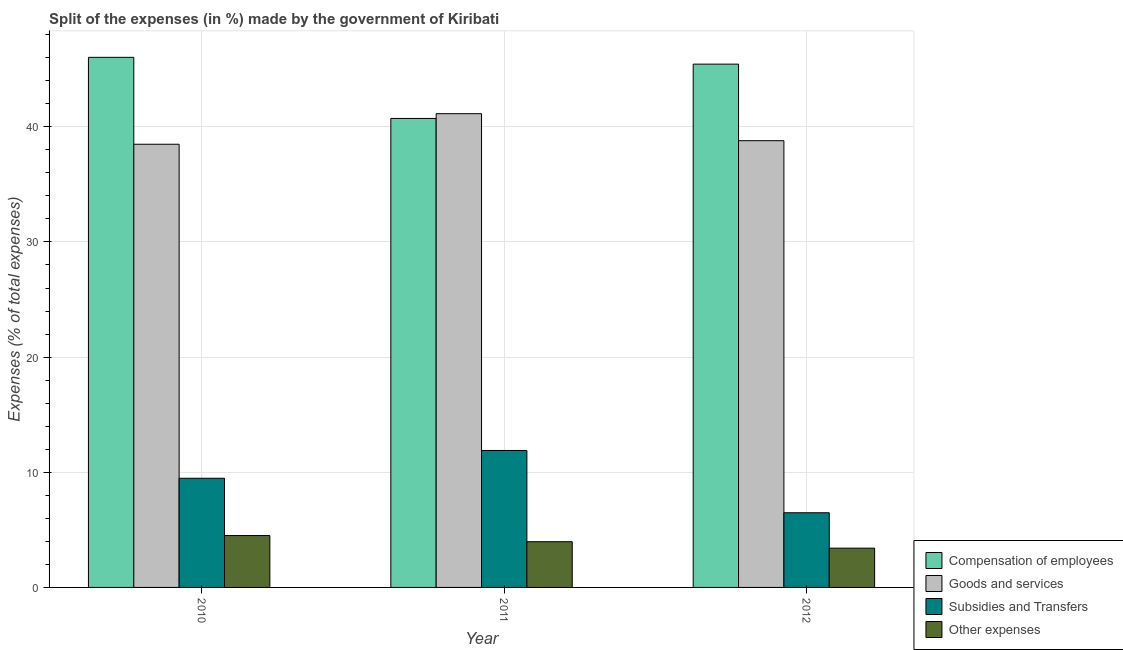How many groups of bars are there?
Your answer should be compact. 3. How many bars are there on the 3rd tick from the right?
Your answer should be very brief. 4. What is the label of the 3rd group of bars from the left?
Make the answer very short. 2012. What is the percentage of amount spent on subsidies in 2011?
Keep it short and to the point. 11.89. Across all years, what is the maximum percentage of amount spent on other expenses?
Offer a terse response. 4.51. Across all years, what is the minimum percentage of amount spent on subsidies?
Keep it short and to the point. 6.48. In which year was the percentage of amount spent on other expenses maximum?
Offer a very short reply. 2010. In which year was the percentage of amount spent on other expenses minimum?
Your answer should be very brief. 2012. What is the total percentage of amount spent on goods and services in the graph?
Your response must be concise. 118.42. What is the difference between the percentage of amount spent on goods and services in 2010 and that in 2012?
Your answer should be compact. -0.31. What is the difference between the percentage of amount spent on goods and services in 2012 and the percentage of amount spent on compensation of employees in 2010?
Offer a very short reply. 0.31. What is the average percentage of amount spent on other expenses per year?
Give a very brief answer. 3.96. In how many years, is the percentage of amount spent on other expenses greater than 26 %?
Provide a succinct answer. 0. What is the ratio of the percentage of amount spent on goods and services in 2011 to that in 2012?
Give a very brief answer. 1.06. Is the percentage of amount spent on other expenses in 2010 less than that in 2011?
Ensure brevity in your answer.  No. What is the difference between the highest and the second highest percentage of amount spent on goods and services?
Offer a terse response. 2.35. What is the difference between the highest and the lowest percentage of amount spent on other expenses?
Provide a succinct answer. 1.1. In how many years, is the percentage of amount spent on compensation of employees greater than the average percentage of amount spent on compensation of employees taken over all years?
Make the answer very short. 2. What does the 1st bar from the left in 2011 represents?
Offer a terse response. Compensation of employees. What does the 1st bar from the right in 2010 represents?
Provide a short and direct response. Other expenses. Is it the case that in every year, the sum of the percentage of amount spent on compensation of employees and percentage of amount spent on goods and services is greater than the percentage of amount spent on subsidies?
Offer a very short reply. Yes. How many years are there in the graph?
Your response must be concise. 3. What is the difference between two consecutive major ticks on the Y-axis?
Give a very brief answer. 10. Are the values on the major ticks of Y-axis written in scientific E-notation?
Provide a succinct answer. No. Does the graph contain grids?
Your answer should be compact. Yes. How are the legend labels stacked?
Provide a succinct answer. Vertical. What is the title of the graph?
Offer a very short reply. Split of the expenses (in %) made by the government of Kiribati. What is the label or title of the X-axis?
Ensure brevity in your answer.  Year. What is the label or title of the Y-axis?
Your response must be concise. Expenses (% of total expenses). What is the Expenses (% of total expenses) of Compensation of employees in 2010?
Your answer should be compact. 46.03. What is the Expenses (% of total expenses) of Goods and services in 2010?
Keep it short and to the point. 38.49. What is the Expenses (% of total expenses) of Subsidies and Transfers in 2010?
Keep it short and to the point. 9.48. What is the Expenses (% of total expenses) in Other expenses in 2010?
Keep it short and to the point. 4.51. What is the Expenses (% of total expenses) in Compensation of employees in 2011?
Give a very brief answer. 40.73. What is the Expenses (% of total expenses) of Goods and services in 2011?
Your response must be concise. 41.14. What is the Expenses (% of total expenses) of Subsidies and Transfers in 2011?
Your answer should be very brief. 11.89. What is the Expenses (% of total expenses) of Other expenses in 2011?
Keep it short and to the point. 3.97. What is the Expenses (% of total expenses) of Compensation of employees in 2012?
Offer a very short reply. 45.44. What is the Expenses (% of total expenses) of Goods and services in 2012?
Give a very brief answer. 38.79. What is the Expenses (% of total expenses) in Subsidies and Transfers in 2012?
Keep it short and to the point. 6.48. What is the Expenses (% of total expenses) in Other expenses in 2012?
Your response must be concise. 3.41. Across all years, what is the maximum Expenses (% of total expenses) in Compensation of employees?
Offer a very short reply. 46.03. Across all years, what is the maximum Expenses (% of total expenses) of Goods and services?
Ensure brevity in your answer.  41.14. Across all years, what is the maximum Expenses (% of total expenses) of Subsidies and Transfers?
Keep it short and to the point. 11.89. Across all years, what is the maximum Expenses (% of total expenses) in Other expenses?
Give a very brief answer. 4.51. Across all years, what is the minimum Expenses (% of total expenses) in Compensation of employees?
Your response must be concise. 40.73. Across all years, what is the minimum Expenses (% of total expenses) of Goods and services?
Your answer should be compact. 38.49. Across all years, what is the minimum Expenses (% of total expenses) of Subsidies and Transfers?
Ensure brevity in your answer.  6.48. Across all years, what is the minimum Expenses (% of total expenses) of Other expenses?
Offer a very short reply. 3.41. What is the total Expenses (% of total expenses) of Compensation of employees in the graph?
Your response must be concise. 132.2. What is the total Expenses (% of total expenses) in Goods and services in the graph?
Your answer should be very brief. 118.42. What is the total Expenses (% of total expenses) in Subsidies and Transfers in the graph?
Keep it short and to the point. 27.85. What is the total Expenses (% of total expenses) in Other expenses in the graph?
Provide a succinct answer. 11.89. What is the difference between the Expenses (% of total expenses) of Compensation of employees in 2010 and that in 2011?
Your answer should be very brief. 5.31. What is the difference between the Expenses (% of total expenses) of Goods and services in 2010 and that in 2011?
Provide a succinct answer. -2.65. What is the difference between the Expenses (% of total expenses) in Subsidies and Transfers in 2010 and that in 2011?
Offer a terse response. -2.41. What is the difference between the Expenses (% of total expenses) of Other expenses in 2010 and that in 2011?
Offer a terse response. 0.53. What is the difference between the Expenses (% of total expenses) in Compensation of employees in 2010 and that in 2012?
Make the answer very short. 0.59. What is the difference between the Expenses (% of total expenses) in Goods and services in 2010 and that in 2012?
Offer a terse response. -0.31. What is the difference between the Expenses (% of total expenses) of Subsidies and Transfers in 2010 and that in 2012?
Offer a very short reply. 2.99. What is the difference between the Expenses (% of total expenses) in Other expenses in 2010 and that in 2012?
Your answer should be compact. 1.1. What is the difference between the Expenses (% of total expenses) in Compensation of employees in 2011 and that in 2012?
Provide a succinct answer. -4.72. What is the difference between the Expenses (% of total expenses) in Goods and services in 2011 and that in 2012?
Your response must be concise. 2.35. What is the difference between the Expenses (% of total expenses) in Subsidies and Transfers in 2011 and that in 2012?
Ensure brevity in your answer.  5.41. What is the difference between the Expenses (% of total expenses) of Other expenses in 2011 and that in 2012?
Your answer should be compact. 0.56. What is the difference between the Expenses (% of total expenses) of Compensation of employees in 2010 and the Expenses (% of total expenses) of Goods and services in 2011?
Your answer should be very brief. 4.89. What is the difference between the Expenses (% of total expenses) in Compensation of employees in 2010 and the Expenses (% of total expenses) in Subsidies and Transfers in 2011?
Make the answer very short. 34.14. What is the difference between the Expenses (% of total expenses) in Compensation of employees in 2010 and the Expenses (% of total expenses) in Other expenses in 2011?
Ensure brevity in your answer.  42.06. What is the difference between the Expenses (% of total expenses) in Goods and services in 2010 and the Expenses (% of total expenses) in Subsidies and Transfers in 2011?
Provide a short and direct response. 26.59. What is the difference between the Expenses (% of total expenses) in Goods and services in 2010 and the Expenses (% of total expenses) in Other expenses in 2011?
Your answer should be compact. 34.51. What is the difference between the Expenses (% of total expenses) in Subsidies and Transfers in 2010 and the Expenses (% of total expenses) in Other expenses in 2011?
Offer a very short reply. 5.51. What is the difference between the Expenses (% of total expenses) in Compensation of employees in 2010 and the Expenses (% of total expenses) in Goods and services in 2012?
Keep it short and to the point. 7.24. What is the difference between the Expenses (% of total expenses) of Compensation of employees in 2010 and the Expenses (% of total expenses) of Subsidies and Transfers in 2012?
Make the answer very short. 39.55. What is the difference between the Expenses (% of total expenses) in Compensation of employees in 2010 and the Expenses (% of total expenses) in Other expenses in 2012?
Keep it short and to the point. 42.62. What is the difference between the Expenses (% of total expenses) in Goods and services in 2010 and the Expenses (% of total expenses) in Subsidies and Transfers in 2012?
Make the answer very short. 32. What is the difference between the Expenses (% of total expenses) in Goods and services in 2010 and the Expenses (% of total expenses) in Other expenses in 2012?
Make the answer very short. 35.08. What is the difference between the Expenses (% of total expenses) of Subsidies and Transfers in 2010 and the Expenses (% of total expenses) of Other expenses in 2012?
Keep it short and to the point. 6.07. What is the difference between the Expenses (% of total expenses) of Compensation of employees in 2011 and the Expenses (% of total expenses) of Goods and services in 2012?
Your response must be concise. 1.93. What is the difference between the Expenses (% of total expenses) of Compensation of employees in 2011 and the Expenses (% of total expenses) of Subsidies and Transfers in 2012?
Your response must be concise. 34.24. What is the difference between the Expenses (% of total expenses) in Compensation of employees in 2011 and the Expenses (% of total expenses) in Other expenses in 2012?
Your answer should be very brief. 37.32. What is the difference between the Expenses (% of total expenses) in Goods and services in 2011 and the Expenses (% of total expenses) in Subsidies and Transfers in 2012?
Your response must be concise. 34.66. What is the difference between the Expenses (% of total expenses) of Goods and services in 2011 and the Expenses (% of total expenses) of Other expenses in 2012?
Your response must be concise. 37.73. What is the difference between the Expenses (% of total expenses) in Subsidies and Transfers in 2011 and the Expenses (% of total expenses) in Other expenses in 2012?
Give a very brief answer. 8.48. What is the average Expenses (% of total expenses) in Compensation of employees per year?
Keep it short and to the point. 44.07. What is the average Expenses (% of total expenses) in Goods and services per year?
Provide a short and direct response. 39.47. What is the average Expenses (% of total expenses) in Subsidies and Transfers per year?
Your response must be concise. 9.29. What is the average Expenses (% of total expenses) of Other expenses per year?
Keep it short and to the point. 3.96. In the year 2010, what is the difference between the Expenses (% of total expenses) of Compensation of employees and Expenses (% of total expenses) of Goods and services?
Your answer should be very brief. 7.55. In the year 2010, what is the difference between the Expenses (% of total expenses) in Compensation of employees and Expenses (% of total expenses) in Subsidies and Transfers?
Your answer should be compact. 36.55. In the year 2010, what is the difference between the Expenses (% of total expenses) in Compensation of employees and Expenses (% of total expenses) in Other expenses?
Your response must be concise. 41.53. In the year 2010, what is the difference between the Expenses (% of total expenses) in Goods and services and Expenses (% of total expenses) in Subsidies and Transfers?
Provide a short and direct response. 29.01. In the year 2010, what is the difference between the Expenses (% of total expenses) in Goods and services and Expenses (% of total expenses) in Other expenses?
Give a very brief answer. 33.98. In the year 2010, what is the difference between the Expenses (% of total expenses) in Subsidies and Transfers and Expenses (% of total expenses) in Other expenses?
Your answer should be compact. 4.97. In the year 2011, what is the difference between the Expenses (% of total expenses) of Compensation of employees and Expenses (% of total expenses) of Goods and services?
Ensure brevity in your answer.  -0.41. In the year 2011, what is the difference between the Expenses (% of total expenses) in Compensation of employees and Expenses (% of total expenses) in Subsidies and Transfers?
Offer a very short reply. 28.83. In the year 2011, what is the difference between the Expenses (% of total expenses) of Compensation of employees and Expenses (% of total expenses) of Other expenses?
Your answer should be very brief. 36.75. In the year 2011, what is the difference between the Expenses (% of total expenses) in Goods and services and Expenses (% of total expenses) in Subsidies and Transfers?
Your answer should be compact. 29.25. In the year 2011, what is the difference between the Expenses (% of total expenses) of Goods and services and Expenses (% of total expenses) of Other expenses?
Ensure brevity in your answer.  37.17. In the year 2011, what is the difference between the Expenses (% of total expenses) in Subsidies and Transfers and Expenses (% of total expenses) in Other expenses?
Your answer should be very brief. 7.92. In the year 2012, what is the difference between the Expenses (% of total expenses) of Compensation of employees and Expenses (% of total expenses) of Goods and services?
Provide a succinct answer. 6.65. In the year 2012, what is the difference between the Expenses (% of total expenses) in Compensation of employees and Expenses (% of total expenses) in Subsidies and Transfers?
Offer a terse response. 38.96. In the year 2012, what is the difference between the Expenses (% of total expenses) of Compensation of employees and Expenses (% of total expenses) of Other expenses?
Keep it short and to the point. 42.03. In the year 2012, what is the difference between the Expenses (% of total expenses) in Goods and services and Expenses (% of total expenses) in Subsidies and Transfers?
Provide a short and direct response. 32.31. In the year 2012, what is the difference between the Expenses (% of total expenses) of Goods and services and Expenses (% of total expenses) of Other expenses?
Ensure brevity in your answer.  35.38. In the year 2012, what is the difference between the Expenses (% of total expenses) of Subsidies and Transfers and Expenses (% of total expenses) of Other expenses?
Provide a succinct answer. 3.07. What is the ratio of the Expenses (% of total expenses) in Compensation of employees in 2010 to that in 2011?
Ensure brevity in your answer.  1.13. What is the ratio of the Expenses (% of total expenses) of Goods and services in 2010 to that in 2011?
Ensure brevity in your answer.  0.94. What is the ratio of the Expenses (% of total expenses) in Subsidies and Transfers in 2010 to that in 2011?
Your answer should be very brief. 0.8. What is the ratio of the Expenses (% of total expenses) of Other expenses in 2010 to that in 2011?
Ensure brevity in your answer.  1.13. What is the ratio of the Expenses (% of total expenses) in Compensation of employees in 2010 to that in 2012?
Keep it short and to the point. 1.01. What is the ratio of the Expenses (% of total expenses) in Subsidies and Transfers in 2010 to that in 2012?
Provide a succinct answer. 1.46. What is the ratio of the Expenses (% of total expenses) of Other expenses in 2010 to that in 2012?
Provide a short and direct response. 1.32. What is the ratio of the Expenses (% of total expenses) of Compensation of employees in 2011 to that in 2012?
Provide a succinct answer. 0.9. What is the ratio of the Expenses (% of total expenses) of Goods and services in 2011 to that in 2012?
Your response must be concise. 1.06. What is the ratio of the Expenses (% of total expenses) of Subsidies and Transfers in 2011 to that in 2012?
Give a very brief answer. 1.83. What is the ratio of the Expenses (% of total expenses) of Other expenses in 2011 to that in 2012?
Provide a short and direct response. 1.16. What is the difference between the highest and the second highest Expenses (% of total expenses) of Compensation of employees?
Make the answer very short. 0.59. What is the difference between the highest and the second highest Expenses (% of total expenses) of Goods and services?
Provide a short and direct response. 2.35. What is the difference between the highest and the second highest Expenses (% of total expenses) of Subsidies and Transfers?
Keep it short and to the point. 2.41. What is the difference between the highest and the second highest Expenses (% of total expenses) in Other expenses?
Your answer should be very brief. 0.53. What is the difference between the highest and the lowest Expenses (% of total expenses) in Compensation of employees?
Offer a very short reply. 5.31. What is the difference between the highest and the lowest Expenses (% of total expenses) in Goods and services?
Make the answer very short. 2.65. What is the difference between the highest and the lowest Expenses (% of total expenses) in Subsidies and Transfers?
Your answer should be compact. 5.41. What is the difference between the highest and the lowest Expenses (% of total expenses) in Other expenses?
Keep it short and to the point. 1.1. 